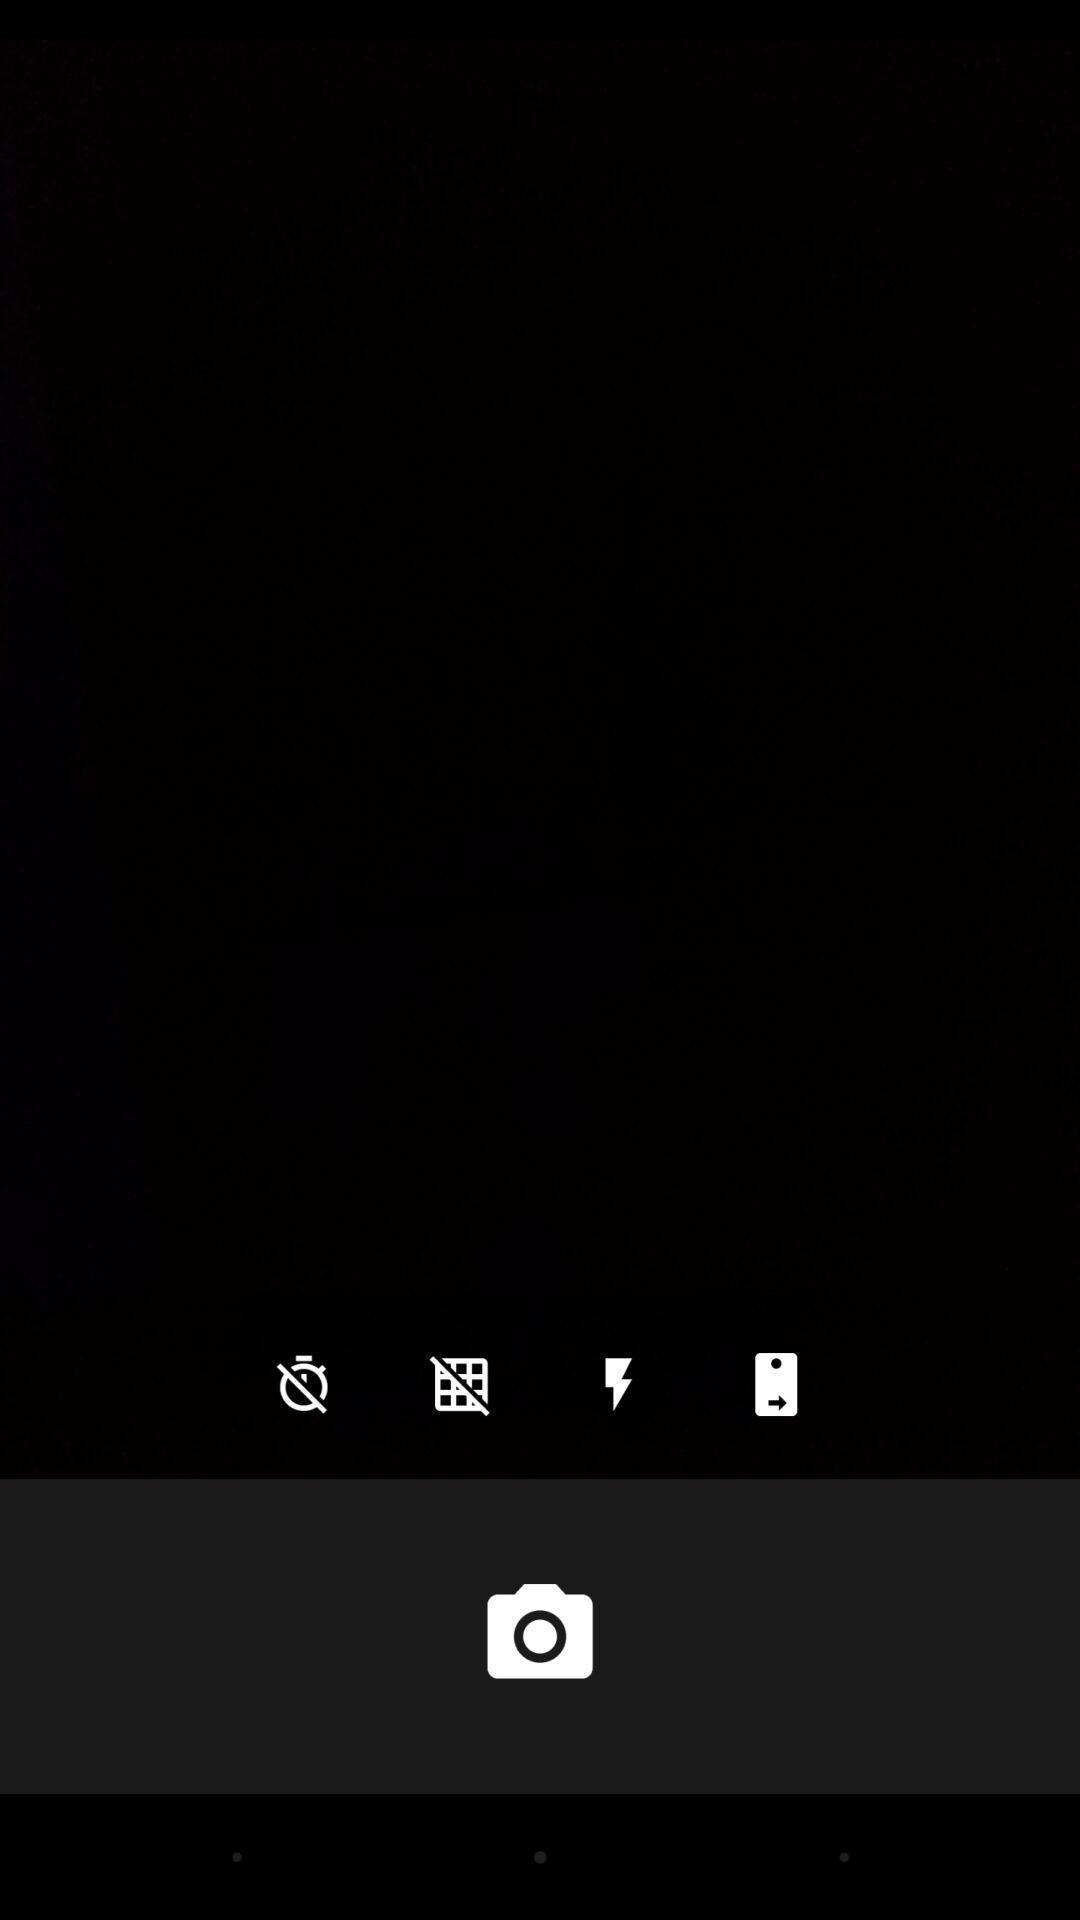Describe this image in words. Screen showing a camera with options. 